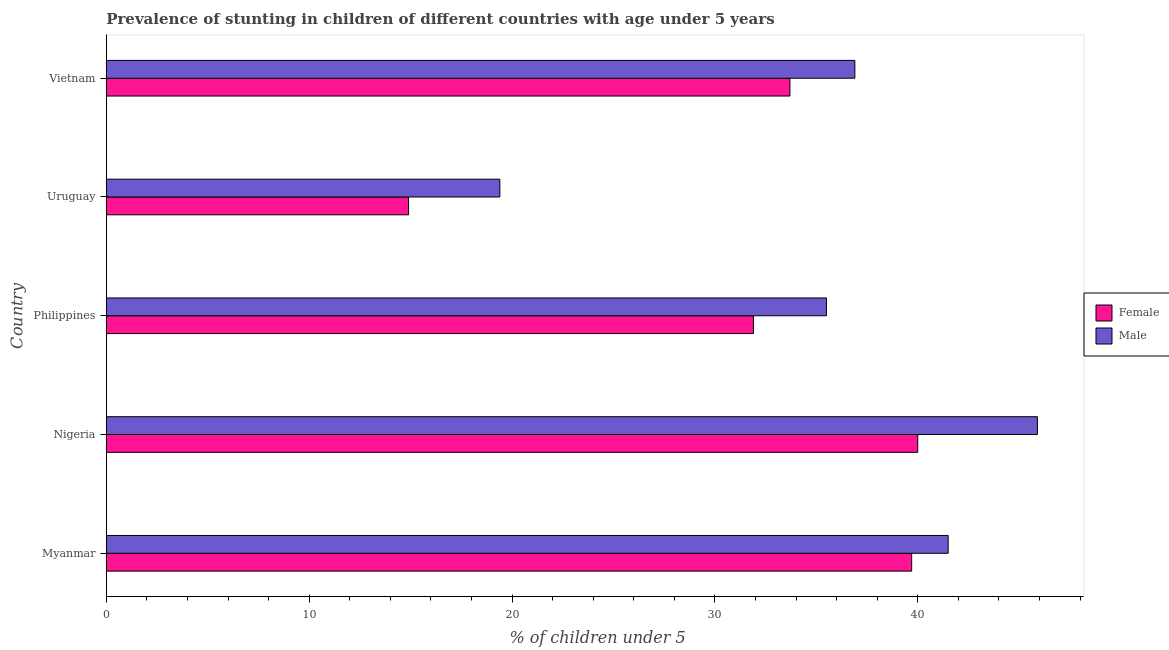How many groups of bars are there?
Keep it short and to the point. 5. Are the number of bars per tick equal to the number of legend labels?
Your answer should be compact. Yes. How many bars are there on the 3rd tick from the top?
Provide a succinct answer. 2. How many bars are there on the 2nd tick from the bottom?
Offer a terse response. 2. What is the label of the 2nd group of bars from the top?
Your answer should be compact. Uruguay. In how many cases, is the number of bars for a given country not equal to the number of legend labels?
Ensure brevity in your answer.  0. What is the percentage of stunted male children in Vietnam?
Provide a succinct answer. 36.9. Across all countries, what is the minimum percentage of stunted female children?
Provide a succinct answer. 14.9. In which country was the percentage of stunted female children maximum?
Provide a short and direct response. Nigeria. In which country was the percentage of stunted female children minimum?
Ensure brevity in your answer.  Uruguay. What is the total percentage of stunted male children in the graph?
Your answer should be compact. 179.2. What is the difference between the percentage of stunted female children in Myanmar and that in Philippines?
Ensure brevity in your answer.  7.8. What is the difference between the percentage of stunted female children in Philippines and the percentage of stunted male children in Nigeria?
Provide a short and direct response. -14. What is the average percentage of stunted male children per country?
Your response must be concise. 35.84. In how many countries, is the percentage of stunted male children greater than 28 %?
Your answer should be compact. 4. What is the ratio of the percentage of stunted female children in Philippines to that in Uruguay?
Provide a succinct answer. 2.14. Is the difference between the percentage of stunted male children in Nigeria and Uruguay greater than the difference between the percentage of stunted female children in Nigeria and Uruguay?
Give a very brief answer. Yes. What is the difference between the highest and the lowest percentage of stunted female children?
Offer a terse response. 25.1. What does the 2nd bar from the bottom in Vietnam represents?
Give a very brief answer. Male. Are all the bars in the graph horizontal?
Offer a very short reply. Yes. How many countries are there in the graph?
Give a very brief answer. 5. What is the difference between two consecutive major ticks on the X-axis?
Offer a very short reply. 10. Are the values on the major ticks of X-axis written in scientific E-notation?
Ensure brevity in your answer.  No. How are the legend labels stacked?
Ensure brevity in your answer.  Vertical. What is the title of the graph?
Ensure brevity in your answer.  Prevalence of stunting in children of different countries with age under 5 years. Does "Female entrants" appear as one of the legend labels in the graph?
Your answer should be compact. No. What is the label or title of the X-axis?
Make the answer very short.  % of children under 5. What is the  % of children under 5 of Female in Myanmar?
Offer a terse response. 39.7. What is the  % of children under 5 of Male in Myanmar?
Make the answer very short. 41.5. What is the  % of children under 5 in Female in Nigeria?
Offer a terse response. 40. What is the  % of children under 5 of Male in Nigeria?
Provide a succinct answer. 45.9. What is the  % of children under 5 of Female in Philippines?
Your answer should be very brief. 31.9. What is the  % of children under 5 in Male in Philippines?
Provide a succinct answer. 35.5. What is the  % of children under 5 of Female in Uruguay?
Ensure brevity in your answer.  14.9. What is the  % of children under 5 in Male in Uruguay?
Your answer should be very brief. 19.4. What is the  % of children under 5 of Female in Vietnam?
Provide a short and direct response. 33.7. What is the  % of children under 5 of Male in Vietnam?
Give a very brief answer. 36.9. Across all countries, what is the maximum  % of children under 5 in Male?
Your answer should be very brief. 45.9. Across all countries, what is the minimum  % of children under 5 of Female?
Offer a very short reply. 14.9. Across all countries, what is the minimum  % of children under 5 of Male?
Give a very brief answer. 19.4. What is the total  % of children under 5 in Female in the graph?
Provide a succinct answer. 160.2. What is the total  % of children under 5 of Male in the graph?
Your response must be concise. 179.2. What is the difference between the  % of children under 5 of Female in Myanmar and that in Nigeria?
Offer a very short reply. -0.3. What is the difference between the  % of children under 5 of Female in Myanmar and that in Uruguay?
Your answer should be compact. 24.8. What is the difference between the  % of children under 5 of Male in Myanmar and that in Uruguay?
Your answer should be compact. 22.1. What is the difference between the  % of children under 5 of Female in Myanmar and that in Vietnam?
Offer a very short reply. 6. What is the difference between the  % of children under 5 in Male in Myanmar and that in Vietnam?
Provide a succinct answer. 4.6. What is the difference between the  % of children under 5 of Female in Nigeria and that in Philippines?
Make the answer very short. 8.1. What is the difference between the  % of children under 5 in Female in Nigeria and that in Uruguay?
Provide a short and direct response. 25.1. What is the difference between the  % of children under 5 of Female in Nigeria and that in Vietnam?
Your answer should be compact. 6.3. What is the difference between the  % of children under 5 of Male in Philippines and that in Vietnam?
Your response must be concise. -1.4. What is the difference between the  % of children under 5 in Female in Uruguay and that in Vietnam?
Ensure brevity in your answer.  -18.8. What is the difference between the  % of children under 5 of Male in Uruguay and that in Vietnam?
Your response must be concise. -17.5. What is the difference between the  % of children under 5 in Female in Myanmar and the  % of children under 5 in Male in Uruguay?
Offer a terse response. 20.3. What is the difference between the  % of children under 5 in Female in Myanmar and the  % of children under 5 in Male in Vietnam?
Give a very brief answer. 2.8. What is the difference between the  % of children under 5 in Female in Nigeria and the  % of children under 5 in Male in Uruguay?
Provide a short and direct response. 20.6. What is the difference between the  % of children under 5 of Female in Philippines and the  % of children under 5 of Male in Uruguay?
Offer a terse response. 12.5. What is the difference between the  % of children under 5 of Female in Philippines and the  % of children under 5 of Male in Vietnam?
Ensure brevity in your answer.  -5. What is the difference between the  % of children under 5 in Female in Uruguay and the  % of children under 5 in Male in Vietnam?
Provide a short and direct response. -22. What is the average  % of children under 5 in Female per country?
Make the answer very short. 32.04. What is the average  % of children under 5 in Male per country?
Give a very brief answer. 35.84. What is the difference between the  % of children under 5 of Female and  % of children under 5 of Male in Philippines?
Provide a short and direct response. -3.6. What is the difference between the  % of children under 5 of Female and  % of children under 5 of Male in Uruguay?
Ensure brevity in your answer.  -4.5. What is the ratio of the  % of children under 5 of Male in Myanmar to that in Nigeria?
Give a very brief answer. 0.9. What is the ratio of the  % of children under 5 in Female in Myanmar to that in Philippines?
Your answer should be compact. 1.24. What is the ratio of the  % of children under 5 of Male in Myanmar to that in Philippines?
Provide a short and direct response. 1.17. What is the ratio of the  % of children under 5 in Female in Myanmar to that in Uruguay?
Your response must be concise. 2.66. What is the ratio of the  % of children under 5 in Male in Myanmar to that in Uruguay?
Your answer should be compact. 2.14. What is the ratio of the  % of children under 5 in Female in Myanmar to that in Vietnam?
Provide a short and direct response. 1.18. What is the ratio of the  % of children under 5 in Male in Myanmar to that in Vietnam?
Your answer should be compact. 1.12. What is the ratio of the  % of children under 5 of Female in Nigeria to that in Philippines?
Provide a short and direct response. 1.25. What is the ratio of the  % of children under 5 in Male in Nigeria to that in Philippines?
Give a very brief answer. 1.29. What is the ratio of the  % of children under 5 of Female in Nigeria to that in Uruguay?
Your answer should be very brief. 2.68. What is the ratio of the  % of children under 5 in Male in Nigeria to that in Uruguay?
Keep it short and to the point. 2.37. What is the ratio of the  % of children under 5 of Female in Nigeria to that in Vietnam?
Offer a very short reply. 1.19. What is the ratio of the  % of children under 5 of Male in Nigeria to that in Vietnam?
Provide a succinct answer. 1.24. What is the ratio of the  % of children under 5 of Female in Philippines to that in Uruguay?
Offer a terse response. 2.14. What is the ratio of the  % of children under 5 of Male in Philippines to that in Uruguay?
Give a very brief answer. 1.83. What is the ratio of the  % of children under 5 of Female in Philippines to that in Vietnam?
Your response must be concise. 0.95. What is the ratio of the  % of children under 5 of Male in Philippines to that in Vietnam?
Give a very brief answer. 0.96. What is the ratio of the  % of children under 5 in Female in Uruguay to that in Vietnam?
Offer a very short reply. 0.44. What is the ratio of the  % of children under 5 in Male in Uruguay to that in Vietnam?
Give a very brief answer. 0.53. What is the difference between the highest and the second highest  % of children under 5 in Female?
Provide a succinct answer. 0.3. What is the difference between the highest and the second highest  % of children under 5 in Male?
Provide a short and direct response. 4.4. What is the difference between the highest and the lowest  % of children under 5 in Female?
Your answer should be very brief. 25.1. What is the difference between the highest and the lowest  % of children under 5 in Male?
Offer a terse response. 26.5. 